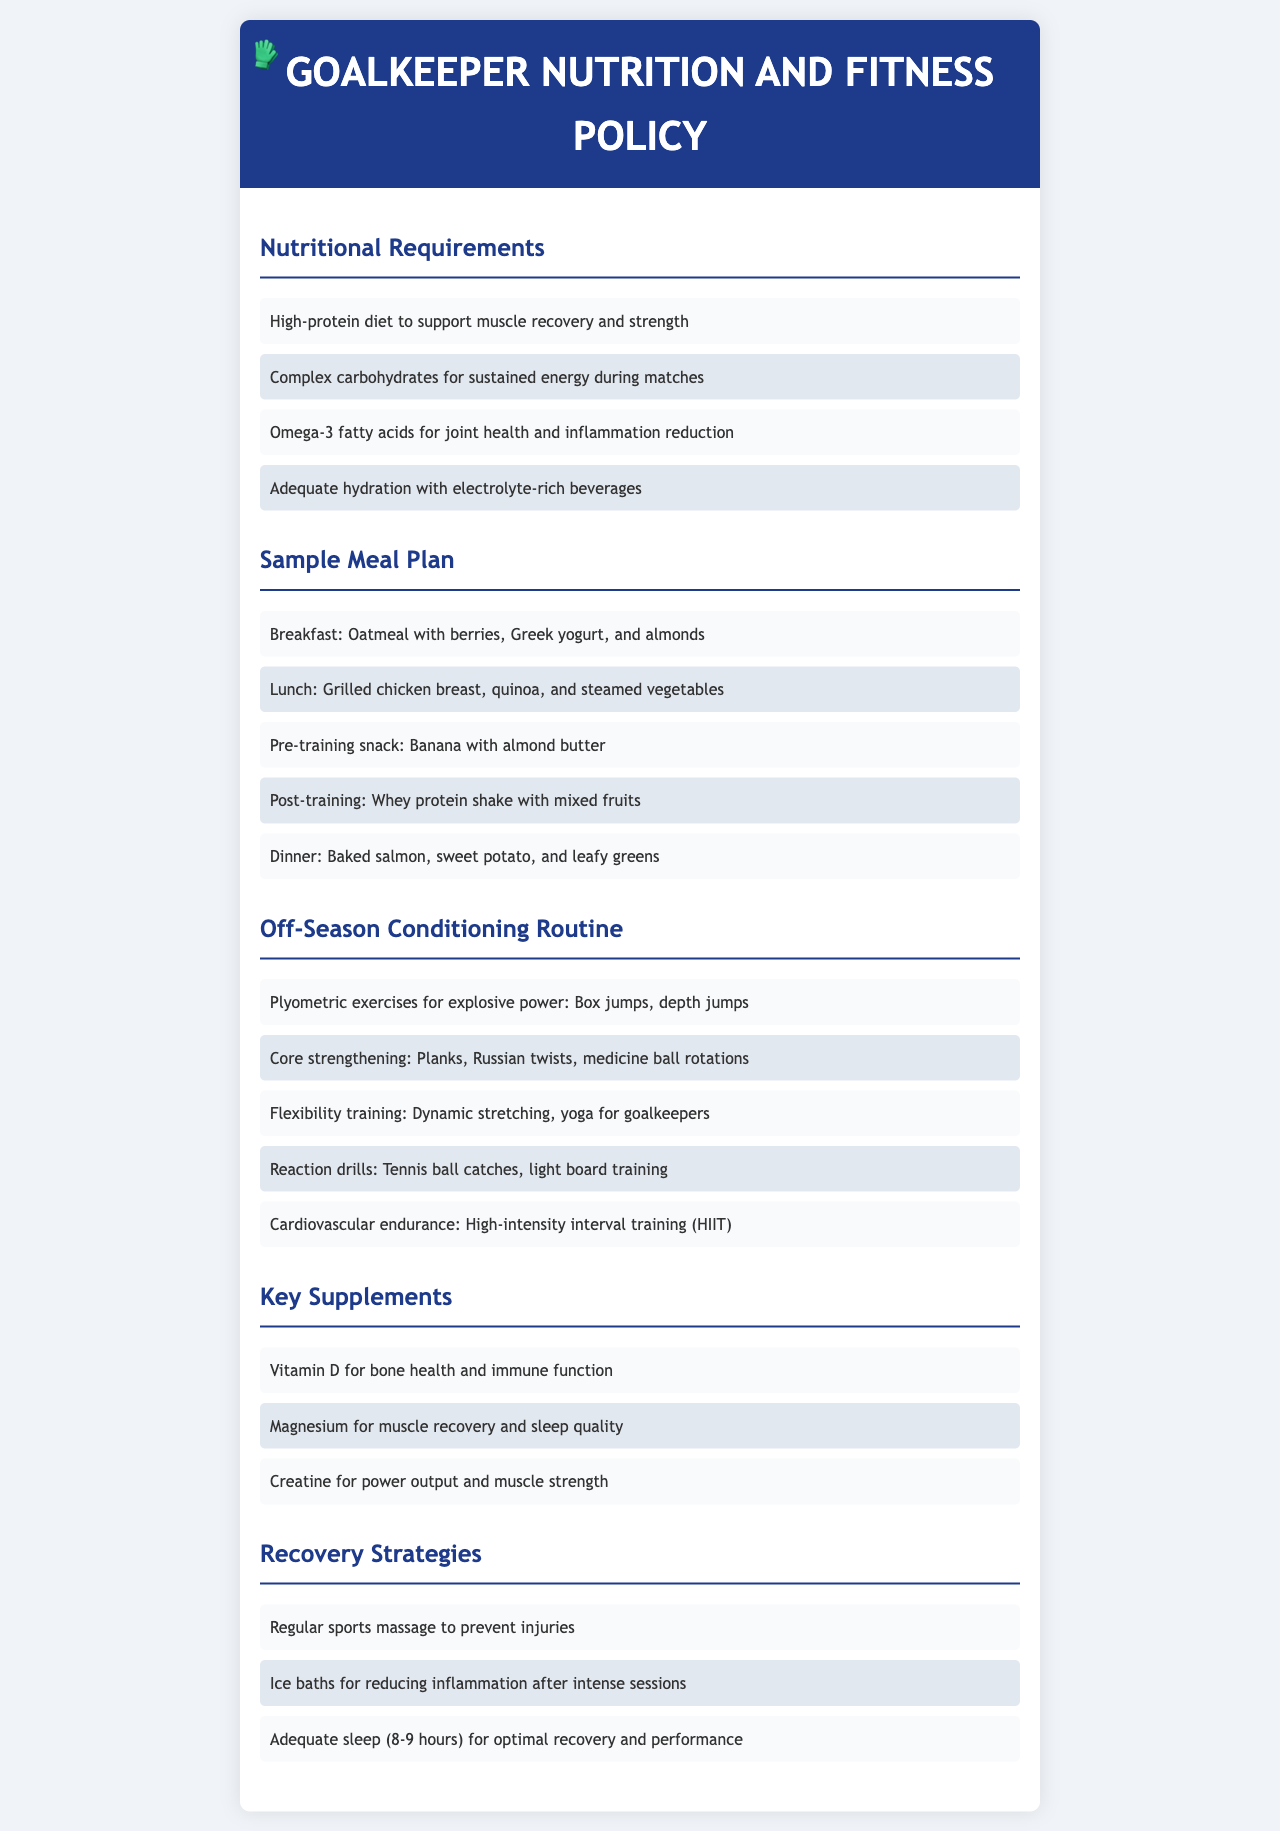What are the dietary fats recommended? The document mentions Omega-3 fatty acids for joint health and inflammation reduction as a key dietary fat.
Answer: Omega-3 fatty acids What is included in the breakfast meal plan? The breakfast meal plan consists of oatmeal with berries, Greek yogurt, and almonds.
Answer: Oatmeal with berries, Greek yogurt, and almonds List one exercise for explosive power. The document specifies box jumps as a plyometric exercise for explosive power.
Answer: Box jumps How many hours of sleep are recommended for optimal recovery? The recovery strategies highlight that adequate sleep is recommended, specifying 8-9 hours.
Answer: 8-9 hours What supplement is mentioned for bone health? Vitamin D is indicated in the key supplements section for bone health and immune function.
Answer: Vitamin D 